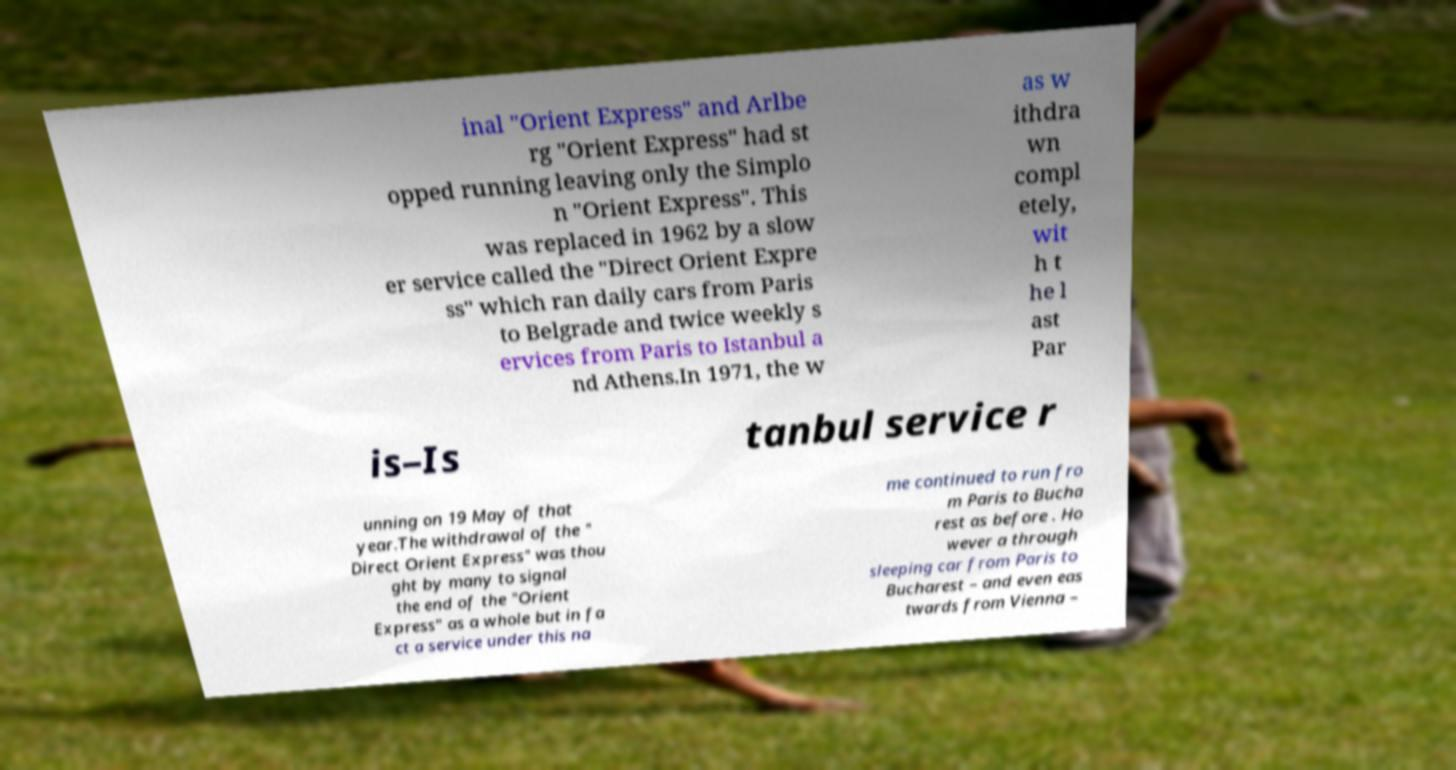Please identify and transcribe the text found in this image. inal "Orient Express" and Arlbe rg "Orient Express" had st opped running leaving only the Simplo n "Orient Express". This was replaced in 1962 by a slow er service called the "Direct Orient Expre ss" which ran daily cars from Paris to Belgrade and twice weekly s ervices from Paris to Istanbul a nd Athens.In 1971, the w as w ithdra wn compl etely, wit h t he l ast Par is–Is tanbul service r unning on 19 May of that year.The withdrawal of the " Direct Orient Express" was thou ght by many to signal the end of the "Orient Express" as a whole but in fa ct a service under this na me continued to run fro m Paris to Bucha rest as before . Ho wever a through sleeping car from Paris to Bucharest – and even eas twards from Vienna – 